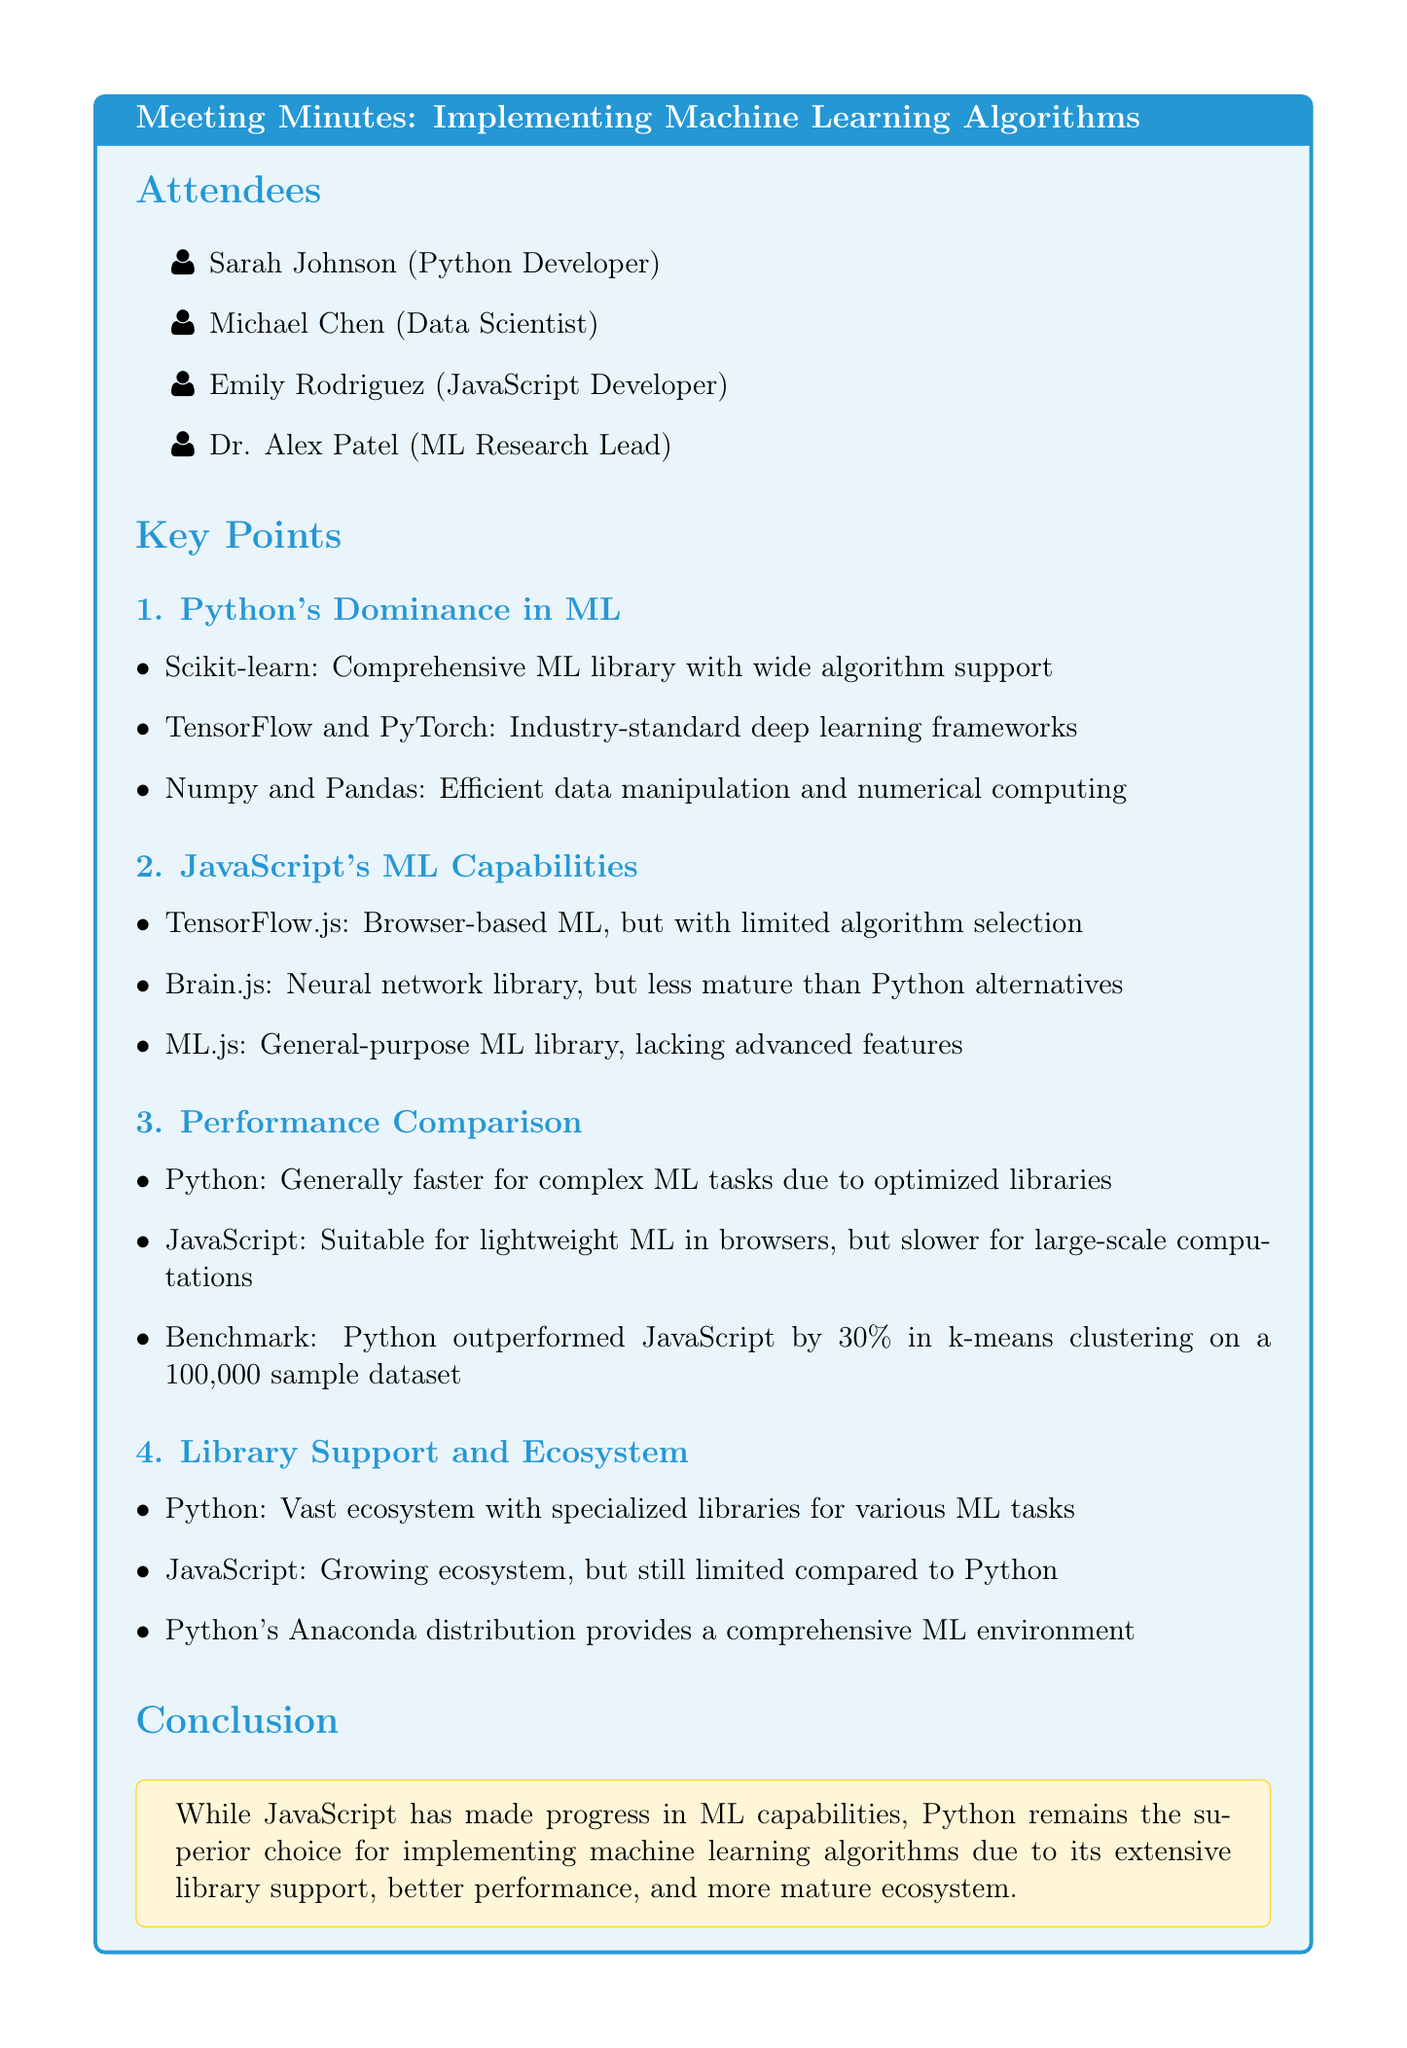What is the meeting topic? The meeting topic is stated at the beginning of the document as "Implementing Machine Learning Algorithms: Python vs JavaScript."
Answer: Implementing Machine Learning Algorithms: Python vs JavaScript Who is the JavaScript Developer in the attendees list? Emily Rodriguez is listed as the JavaScript Developer among the attendees.
Answer: Emily Rodriguez Which library is mentioned as a comprehensive ML library in Python? Scikit-learn is identified as a comprehensive ML library with wide algorithm support in Python.
Answer: Scikit-learn How much faster did Python outperform JavaScript in k-means clustering? The document specifies that Python outperformed JavaScript by 30 percent in a benchmark.
Answer: 30 percent What concluding statement is made regarding Python's superiority? The conclusion states that Python is the superior choice for implementing machine learning algorithms.
Answer: superior choice What is Python's Anaconda distribution known for? The document mentions that Python's Anaconda distribution provides a comprehensive ML environment.
Answer: comprehensive ML environment List one library mentioned that supports ML in JavaScript. The document lists TensorFlow.js as a library that supports machine learning in JavaScript.
Answer: TensorFlow.js What is the performance of JavaScript in large-scale computations compared to Python? It is stated that JavaScript is slower for large-scale computations compared to Python.
Answer: slower How does the document categorize the ecosystem of Python libraries? The document refers to Python's ecosystem as vast with specialized libraries for various ML tasks.
Answer: vast ecosystem 